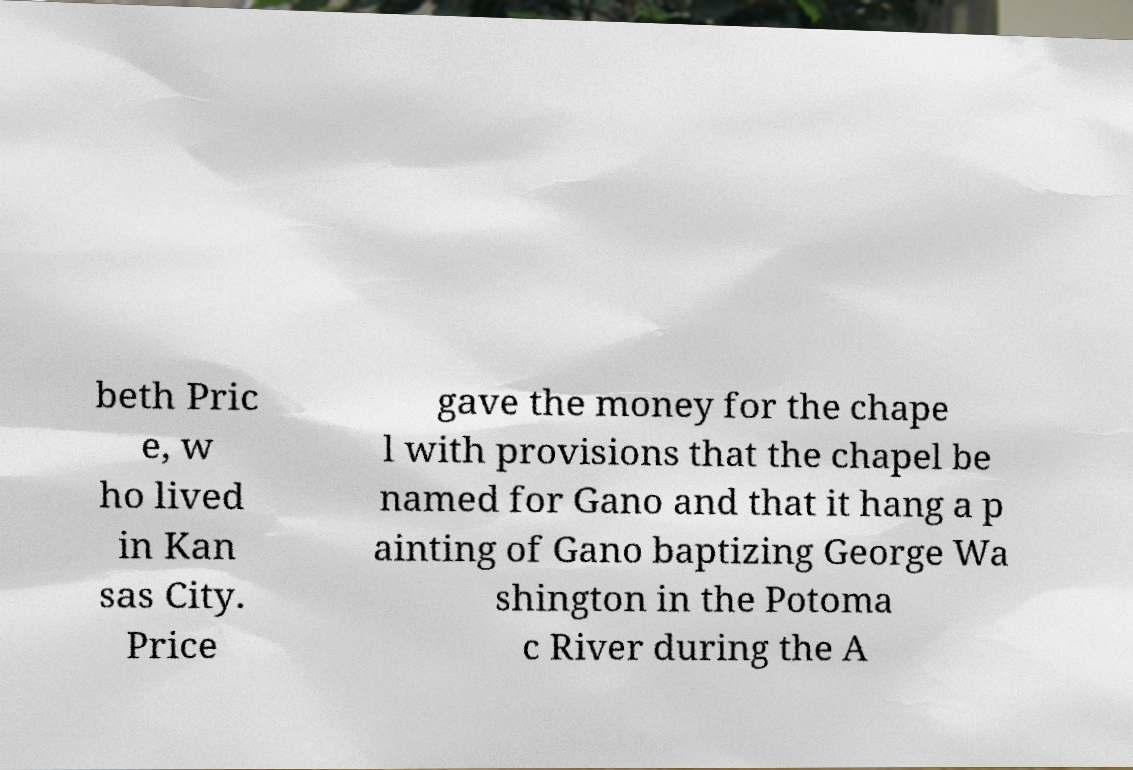Could you extract and type out the text from this image? beth Pric e, w ho lived in Kan sas City. Price gave the money for the chape l with provisions that the chapel be named for Gano and that it hang a p ainting of Gano baptizing George Wa shington in the Potoma c River during the A 